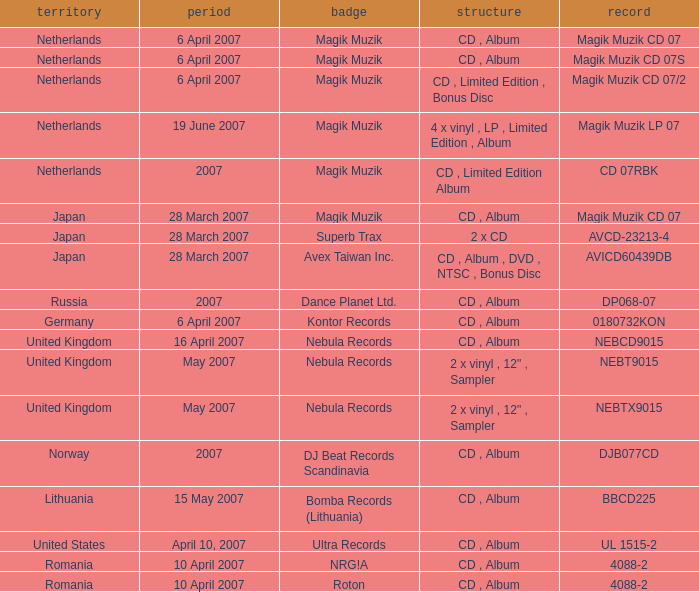For the catalog title DP068-07, what formats are available? CD , Album. 